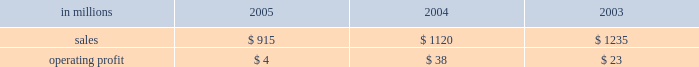Wood products sales in the united states in 2005 of $ 1.6 billion were up 3% ( 3 % ) from $ 1.5 billion in 2004 and 18% ( 18 % ) from $ 1.3 billion in 2003 .
Average price realiza- tions for lumber were up 6% ( 6 % ) and 21% ( 21 % ) in 2005 compared with 2004 and 2003 , respectively .
Lumber sales volumes in 2005 were up 5% ( 5 % ) versus 2004 and 10% ( 10 % ) versus 2003 .
Average sales prices for plywood were down 4% ( 4 % ) from 2004 , but were 15% ( 15 % ) higher than in 2003 .
Plywood sales volumes in 2005 were slightly higher than 2004 and 2003 .
Operating profits in 2005 were 18% ( 18 % ) lower than 2004 , but nearly three times higher than 2003 .
Lower average plywood prices and higher raw material costs more than offset the effects of higher average lumber prices , volume increases and a positive sales mix .
In 2005 , log costs were up 9% ( 9 % ) versus 2004 , negatively im- pacting both plywood and lumber profits .
Lumber and plywood operating costs also reflected substantially higher glue and natural gas costs versus both 2004 and looking forward to the first quarter of 2006 , a con- tinued strong housing market , combined with low prod- uct inventory in the distribution chain , should translate into continued strong lumber and plywood demand .
However , a possible softening of housing starts and higher interest rates later in the year could put down- ward pressure on pricing in the second half of 2006 .
Specialty businesses and other the specialty businesses and other segment in- cludes the operating results of arizona chemical , euro- pean distribution and , prior to its closure in 2003 , our natchez , mississippi chemical cellulose pulp mill .
Also included are certain divested businesses whose results are included in this segment for periods prior to their sale or closure .
This segment 2019s 2005 net sales declined 18% ( 18 % ) and 26% ( 26 % ) from 2004 and 2003 , respectively .
Operating profits in 2005 were down substantially from both 2004 and 2003 .
The decline in sales principally reflects declining contributions from businesses sold or closed .
Operating profits were also affected by higher energy and raw material costs in our chemical business .
Specialty businesses and other in millions 2005 2004 2003 .
Chemicals sales were $ 692 million in 2005 , com- pared with $ 672 million in 2004 and $ 625 million in 2003 .
Although demand was strong for most arizona chemical product lines , operating profits in 2005 were 84% ( 84 % ) and 83% ( 83 % ) lower than in 2004 and 2003 , re- spectively , due to higher energy costs in the u.s. , and higher prices and reduced availability for crude tall oil ( cto ) .
In the united states , energy costs increased 41% ( 41 % ) compared to 2004 due to higher natural gas prices and supply interruption costs .
Cto prices increased 26% ( 26 % ) compared to 2004 , as certain energy users turned to cto as a substitute fuel for high-cost alternative energy sources such as natural gas and fuel oil .
European cto receipts decreased 30% ( 30 % ) compared to 2004 due to lower yields following the finnish paper industry strike and a swedish storm that limited cto throughput and corre- sponding sales volumes .
Other businesses in this operating segment include operations that have been sold , closed , or are held for sale , principally the european distribution business , the oil and gas and mineral royalty business , decorative products , retail packaging , and the natchez chemical cellulose pulp mill .
Sales for these businesses were ap- proximately $ 223 million in 2005 ( mainly european distribution and decorative products ) compared with $ 448 million in 2004 ( mainly european distribution and decorative products ) , and $ 610 million in 2003 .
Liquidity and capital resources overview a major factor in international paper 2019s liquidity and capital resource planning is its generation of operat- ing cash flow , which is highly sensitive to changes in the pricing and demand for our major products .
While changes in key cash operating costs , such as energy and raw material costs , do have an effect on operating cash generation , we believe that our strong focus on cost controls has improved our cash flow generation over an operating cycle .
As a result , we believe that we are well positioned for improvements in operating cash flow should prices and worldwide economic conditions im- prove in the future .
As part of our continuing focus on improving our return on investment , we have focused our capital spending on improving our key platform businesses in north america and in geographic areas with strong growth opportunities .
Spending levels have been kept below the level of depreciation and amortization charges for each of the last three years , and we anticipate con- tinuing this approach in 2006 .
With the low interest rate environment in 2005 , financing activities have focused largely on the repay- ment or refinancing of higher coupon debt , resulting in a net reduction in debt of approximately $ 1.7 billion in 2005 .
We plan to continue this program , with addi- tional reductions anticipated as our previously an- nounced transformation plan progresses in 2006 .
Our liquidity position continues to be strong , with approx- imately $ 3.2 billion of committed liquidity to cover fu- ture short-term cash flow requirements not met by operating cash flows. .
What percentage of specialty businesses sales where due to chemicals sales in 2004? 
Computations: (672 / 1120)
Answer: 0.6. 